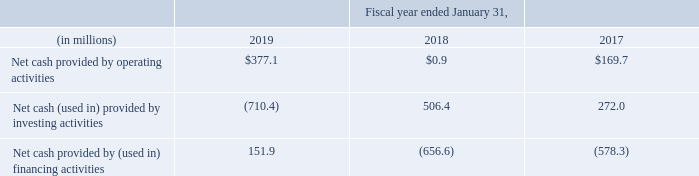LIQUIDITY AND CAPITAL RESOURCES
Our primary source of cash is from the sale of our software and related services. Our primary use of cash is payment of our operating costs, which consist primarily of employee-related expenses, such as compensation and benefits, as well as general operating expenses for marketing, facilities and overhead costs. In addition to operating expenses, we also use cash to fund our stock repurchase program and invest in our growth initiatives, which include acquisitions of products, technology and businesses. See further discussion of these items below.
At January 31, 2019, our principal sources of liquidity were cash, cash equivalents, and marketable securities totaling $953.6 million and net accounts receivable of $474.3 million
On December 17, 2018, Autodesk entered into a new Credit Agreement (the “Credit Agreement”) for an unsecured revolving loan facility in the aggregate principal amount of $650.0 million, with an option to request increases in the amount of the credit facility by up to an additional $350.0 million. The Credit Agreement replaced and terminated our $400.0 million Amended and Restated Credit Agreement. The maturity date on the line of credit facility is December 2023. At January 31, 2019, Autodesk had no outstanding borrowings on this line of credit. As of March 25, 2019, we have no amounts outstanding under the credit facility. See Part II, Item 8, Note 8, "Borrowing Arrangements," in the Notes to Consolidated Financial Statements for further discussion on our covenant requirements. If we are unable to remain in compliance with the covenants, we will not be able to draw on our credit facility.
On December 17, 2018, we also entered into a Term Loan Agreement (the “Term Loan Agreement”) which provided for a delayed draw term loan facility in the aggregate principal amount of $500.0 million. On December 19, 2018, we borrowed a $500.0 million term loan under the Term Loan Agreement in connection with the acquisition of PlanGrid. See Part II, Item 8,Note 8, "Borrowing Arrangements," in the Notes to Consolidated Financial Statements for further discussion on the Term Loan Agreement terms and Part II, Item 8, Note 6, "Acquisitions" for further discussion on the PlanGrid acquisition.
In addition to the term loan, as of January 31, 2019, we have $1.6 billion aggregate principal amount of Notes outstanding. See Part II, Item 8, Note 8, "Borrowing Arrangements," in the Notes to Consolidated Financial Statements for further discussion.
Our cash and cash equivalents are held by diversified financial institutions globally. Our primary commercial banking relationship is with Citigroup and its global affiliates. In addition, Citibank N.A., an affiliate of Citigroup, is one of the lead lenders and agent in the syndicate of our $650.0 million line of credit.
Long-term cash requirements for items other than normal operating expenses are anticipated for the following: repayment of debt; common stock repurchases; the acquisition of businesses, software products, or technologies complementary to our business; and capital expenditures, including the purchase and implementation of internal-use software applications
Our cash, cash equivalents, and marketable securities balances are concentrated in a few locations around the world, with substantial amounts held outside of the United States. As of January 31, 2019, approximately 52% of our total cash or cash equivalents and marketable securities are located in foreign jurisdictions and that percentage will fluctuate subject to business needs. There are several factors that can impact our ability to utilize foreign cash balances, such as foreign exchange restrictions, foreign regulatory restrictions or adverse tax costs. The Tax Act includes a mandatory one-time tax on accumulated earnings of foreign subsidiaries and generally eliminates U.S. taxes on foreign subsidiary distributions in future periods. As a result, earnings in foreign jurisdictions are generally available for distribution to the U.S. with little to no incremental U.S. taxes. We regularly review our capital structure and consider a variety of potential financing alternatives and planning strategies to ensure we have the proper liquidity available in the locations in which it is needed. We expect to meet our liquidity needs through a combination of current cash balances, ongoing cash flows, and external borrowings.
Cash from operations could also be affected by various risks and uncertainties, including, but not limited to the risks detailed in Part I, Item 1A titled “Risk Factors.” However, based on our current business plan and revenue prospects, we believe that our existing balances, our anticipated cash flows from operations and our available credit facility will be sufficient to meet our working capital and operating resource expenditure requirements for at least the next 12 months.
Our revenue, earnings, cash flows, receivables, and payables are subject to fluctuations due to changes in foreign currency exchange rates, for which we have put in place foreign currency contracts as part of our risk management strategy. See Part II, Item 7A, “Quantitative and Qualitative Disclosures about Market Risk” for further discussion.
Net cash provided by operating activities of $377.1 million for fiscal 2019 consisted of $371.8 million of non-cash expenses, including stock-based compensation expense, restructuring charges, net, depreciation, amortization and accretion expense, offsetting our net loss of $80.8 million, and included $86.1 million of cash flow provided by changes in operating assets and liabilities.
The primary working capital source of cash was an increase in deferred revenue from $1,955.1 million as of January 31, 2018, to $2,091.4 million as of January 31, 2019. The primary working capital uses of cash were decreases in accounts payable and other accrued liabilities.
Net cash used in investing activities was $710.4 million for fiscal 2019 and was primarily due to acquisitions, net of cash acquired and purchases of marketable securities. These cash outflows were partially offset by sales and maturities of marketable securities.
At January 31, 2019, our short-term investment portfolio had an estimated fair value of $67.6 million and a cost basis of $62.8 million. The portfolio fair value consisted of $60.3 million of trading securities that were invested in a defined set of mutual funds as directed by the participants in our Deferred Compensation Plan (see Note 7, “Deferred Compensation,” in the Notes to Consolidated Financial Statements for further discussion) and $7.3 million invested in other available-for-sale shortterm securities.
Net cash provided by financing activities was $151.9 million in fiscal 2019 and was primarily due to proceeds from debt issuance, net of discount and proceeds from issuance of stock. These cash inflows were partially offset by repurchases of our common stock and taxes paid related to net share settlement of equity awards.
What was the difference in net cash provided by operating activities in 2019? 377.1-0.9 
Answer: 376.2. What does Autodesk use cash for? Our primary use of cash is payment of our operating costs, which consist primarily of employee-related expenses, such as compensation and benefits, as well as general operating expenses for marketing, facilities and overhead costs. in addition to operating expenses, we also use cash to fund our stock repurchase program and invest in our growth initiatives, which include acquisitions of products, technology and businesses. What was the net cash used in investing activities in 2019 used for? Net cash used in investing activities was $710.4 million for fiscal 2019 and was primarily due to acquisitions, net of cash acquired and purchases of marketable securities. these cash outflows were partially offset by sales and maturities of marketable securities. How much is the increase in primary working capital use of cash from 2018 to 2019?
Answer scale should be: million. 2,091.4-1,955.1
Answer: 136.3. How much of company's cash equivalents and marketable securities are located in foreign jurisdictions as of 31 Jan 2019? 52%. How much did the net cash provided by operating activities gain from fiscal year ending 31 January, 2019 compared to that of fiscal year ending 31 January, 2017?
Answer scale should be: percent. (377.1-169.7)/169.7 
Answer: 122.22. 